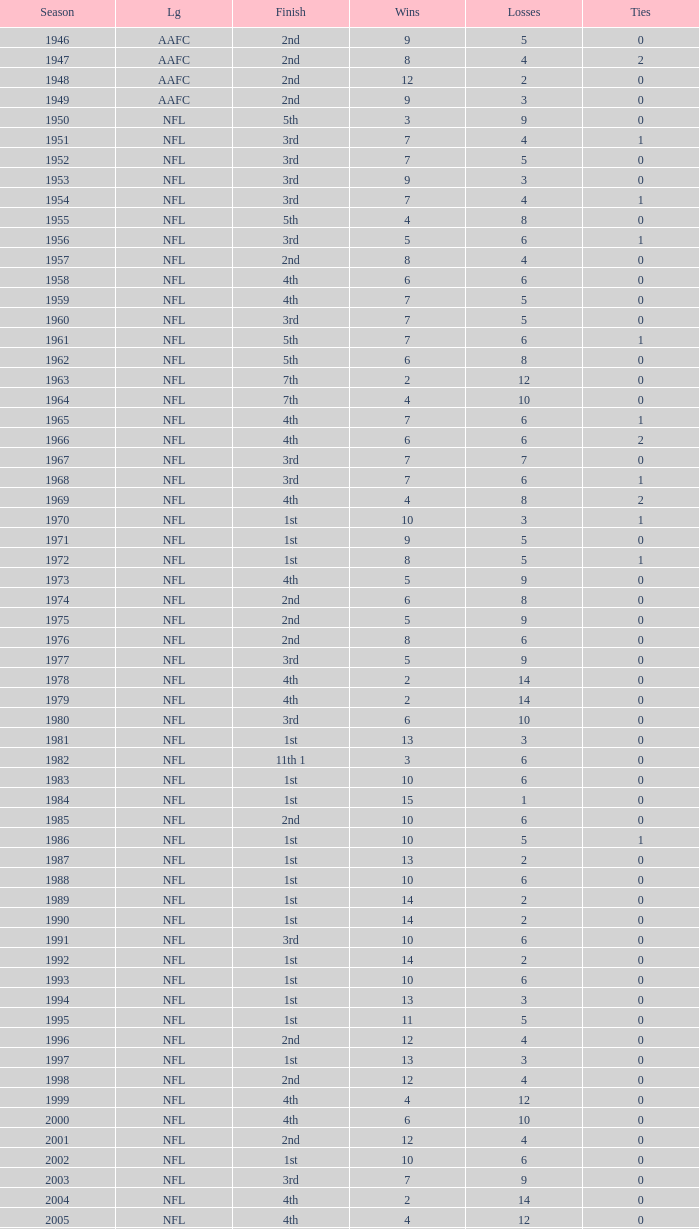Can you parse all the data within this table? {'header': ['Season', 'Lg', 'Finish', 'Wins', 'Losses', 'Ties'], 'rows': [['1946', 'AAFC', '2nd', '9', '5', '0'], ['1947', 'AAFC', '2nd', '8', '4', '2'], ['1948', 'AAFC', '2nd', '12', '2', '0'], ['1949', 'AAFC', '2nd', '9', '3', '0'], ['1950', 'NFL', '5th', '3', '9', '0'], ['1951', 'NFL', '3rd', '7', '4', '1'], ['1952', 'NFL', '3rd', '7', '5', '0'], ['1953', 'NFL', '3rd', '9', '3', '0'], ['1954', 'NFL', '3rd', '7', '4', '1'], ['1955', 'NFL', '5th', '4', '8', '0'], ['1956', 'NFL', '3rd', '5', '6', '1'], ['1957', 'NFL', '2nd', '8', '4', '0'], ['1958', 'NFL', '4th', '6', '6', '0'], ['1959', 'NFL', '4th', '7', '5', '0'], ['1960', 'NFL', '3rd', '7', '5', '0'], ['1961', 'NFL', '5th', '7', '6', '1'], ['1962', 'NFL', '5th', '6', '8', '0'], ['1963', 'NFL', '7th', '2', '12', '0'], ['1964', 'NFL', '7th', '4', '10', '0'], ['1965', 'NFL', '4th', '7', '6', '1'], ['1966', 'NFL', '4th', '6', '6', '2'], ['1967', 'NFL', '3rd', '7', '7', '0'], ['1968', 'NFL', '3rd', '7', '6', '1'], ['1969', 'NFL', '4th', '4', '8', '2'], ['1970', 'NFL', '1st', '10', '3', '1'], ['1971', 'NFL', '1st', '9', '5', '0'], ['1972', 'NFL', '1st', '8', '5', '1'], ['1973', 'NFL', '4th', '5', '9', '0'], ['1974', 'NFL', '2nd', '6', '8', '0'], ['1975', 'NFL', '2nd', '5', '9', '0'], ['1976', 'NFL', '2nd', '8', '6', '0'], ['1977', 'NFL', '3rd', '5', '9', '0'], ['1978', 'NFL', '4th', '2', '14', '0'], ['1979', 'NFL', '4th', '2', '14', '0'], ['1980', 'NFL', '3rd', '6', '10', '0'], ['1981', 'NFL', '1st', '13', '3', '0'], ['1982', 'NFL', '11th 1', '3', '6', '0'], ['1983', 'NFL', '1st', '10', '6', '0'], ['1984', 'NFL', '1st', '15', '1', '0'], ['1985', 'NFL', '2nd', '10', '6', '0'], ['1986', 'NFL', '1st', '10', '5', '1'], ['1987', 'NFL', '1st', '13', '2', '0'], ['1988', 'NFL', '1st', '10', '6', '0'], ['1989', 'NFL', '1st', '14', '2', '0'], ['1990', 'NFL', '1st', '14', '2', '0'], ['1991', 'NFL', '3rd', '10', '6', '0'], ['1992', 'NFL', '1st', '14', '2', '0'], ['1993', 'NFL', '1st', '10', '6', '0'], ['1994', 'NFL', '1st', '13', '3', '0'], ['1995', 'NFL', '1st', '11', '5', '0'], ['1996', 'NFL', '2nd', '12', '4', '0'], ['1997', 'NFL', '1st', '13', '3', '0'], ['1998', 'NFL', '2nd', '12', '4', '0'], ['1999', 'NFL', '4th', '4', '12', '0'], ['2000', 'NFL', '4th', '6', '10', '0'], ['2001', 'NFL', '2nd', '12', '4', '0'], ['2002', 'NFL', '1st', '10', '6', '0'], ['2003', 'NFL', '3rd', '7', '9', '0'], ['2004', 'NFL', '4th', '2', '14', '0'], ['2005', 'NFL', '4th', '4', '12', '0'], ['2006', 'NFL', '3rd', '7', '9', '0'], ['2007', 'NFL', '3rd', '5', '11', '0'], ['2008', 'NFL', '2nd', '7', '9', '0'], ['2009', 'NFL', '2nd', '8', '8', '0'], ['2010', 'NFL', '3rd', '6', '10', '0'], ['2011', 'NFL', '1st', '13', '3', '0'], ['2012', 'NFL', '1st', '11', '4', '1'], ['2013', 'NFL', '2nd', '6', '2', '0']]} What is the highest wins for the NFL with a finish of 1st, and more than 6 losses? None. 